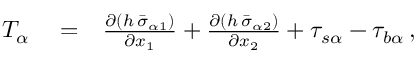Convert formula to latex. <formula><loc_0><loc_0><loc_500><loc_500>\begin{array} { r l r } { T _ { \alpha } } & = } & { \frac { \partial \left ( h \, \bar { \sigma } _ { \alpha 1 } \right ) } { \partial x _ { 1 } } + \frac { \partial \left ( h \, \bar { \sigma } _ { \alpha 2 } \right ) } { \partial x _ { 2 } } + \tau _ { s \alpha } - \tau _ { b \alpha } \, , } \end{array}</formula> 